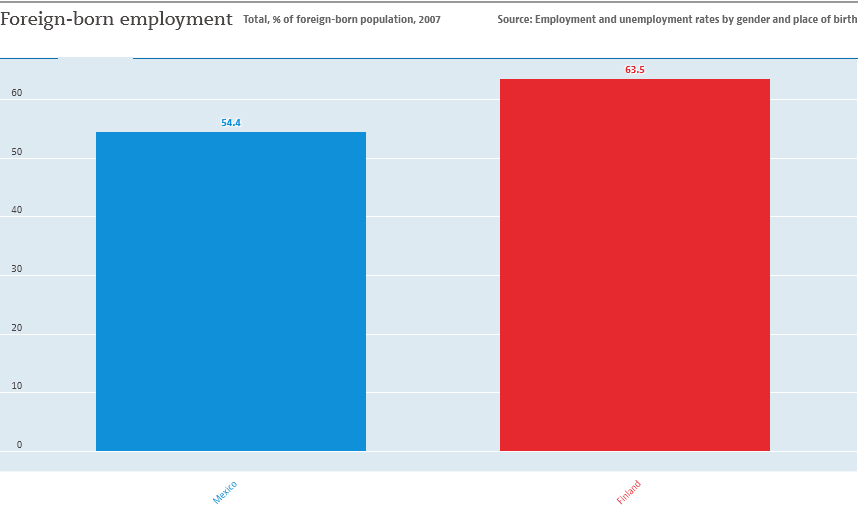Highlight a few significant elements in this photo. The country with the highest value is Finland, as it is reported to come from both Mexico and Finland. The graph shows two colors. 